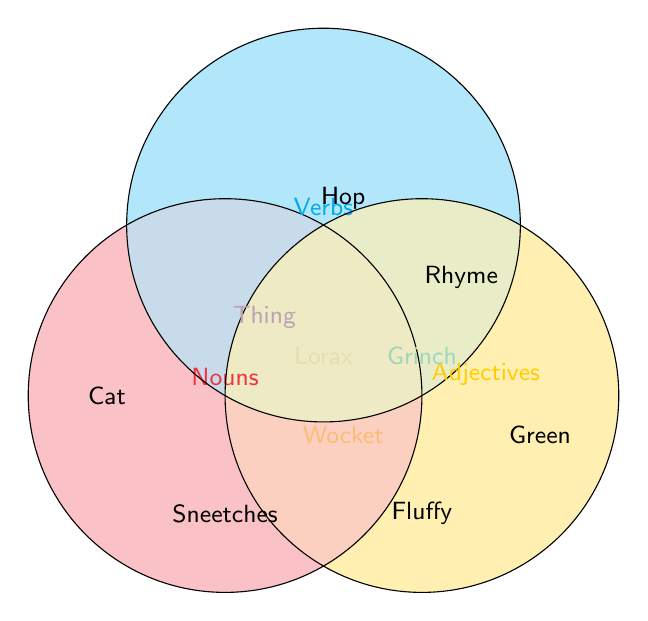Which part of speech does "Cat" belong to? "Cat" is in the red circle which represents Nouns.
Answer: Noun Which parts of speech contain the word "Grinch"? "Grinch" is in the intersections of Nouns and Adjectives, and in the intersection of all three circles (Nouns, Verbs, Adjectives).
Answer: Nouns, Adjectives, Verbs Which words belong to both Nouns and Verbs but not Adjectives? The word "Thing" is in the intersection of Nouns and Verbs only.
Answer: Thing Which parts of speech do “Sneetches” belong to? "Sneetches" is in the list of words that belong to Nouns and Adjectives but not Verbs.
Answer: Nouns, Adjectives Which part of speech does "Rhyme" belong to? "Rhyme" is in the blue circle which represents Verbs.
Answer: Verb How many words are there in the intersection of all three parts of speech? There's only one word in the intersection of all three circles: "Lorax."
Answer: One Between Nouns, Verbs, and Adjectives, which has the least overlapping words with other categories? Nouns have three overlapping words: Thing, Wocket, and Grinch, whereas Verbs have three overlapping words and Adjectives have four.
Answer: Nouns Which parts of speech do “Wocket” belong to? "Wocket" is in the intersection of Nouns and Adjectives but not Verbs.
Answer: Nouns, Adjectives 